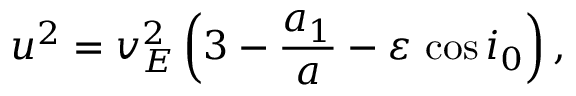Convert formula to latex. <formula><loc_0><loc_0><loc_500><loc_500>u ^ { 2 } = v _ { E } ^ { 2 } \left ( 3 - \frac { a _ { 1 } } { a } - \varepsilon \, \cos i _ { 0 } \right ) ,</formula> 